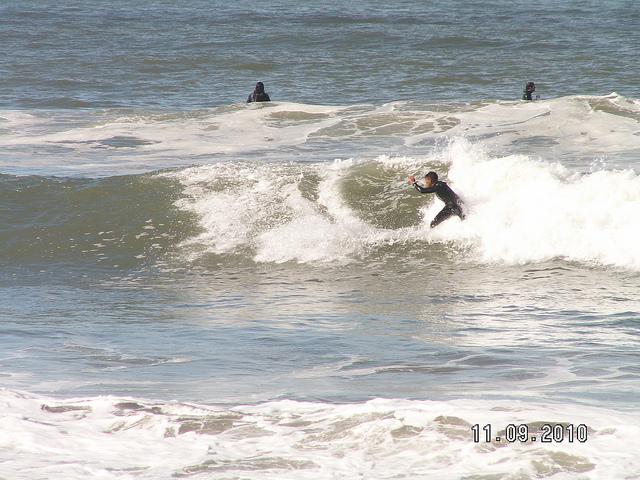Is it high tide?
Quick response, please. Yes. How many people are surfing?
Give a very brief answer. 3. Is anyone swimming?
Be succinct. No. How many waves are pictured?
Keep it brief. 3. 